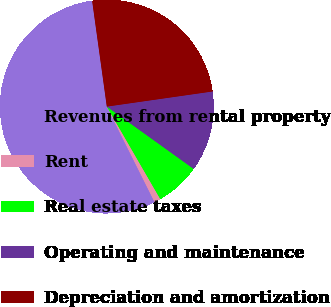Convert chart. <chart><loc_0><loc_0><loc_500><loc_500><pie_chart><fcel>Revenues from rental property<fcel>Rent<fcel>Real estate taxes<fcel>Operating and maintenance<fcel>Depreciation and amortization<nl><fcel>55.19%<fcel>0.96%<fcel>6.75%<fcel>12.17%<fcel>24.93%<nl></chart> 